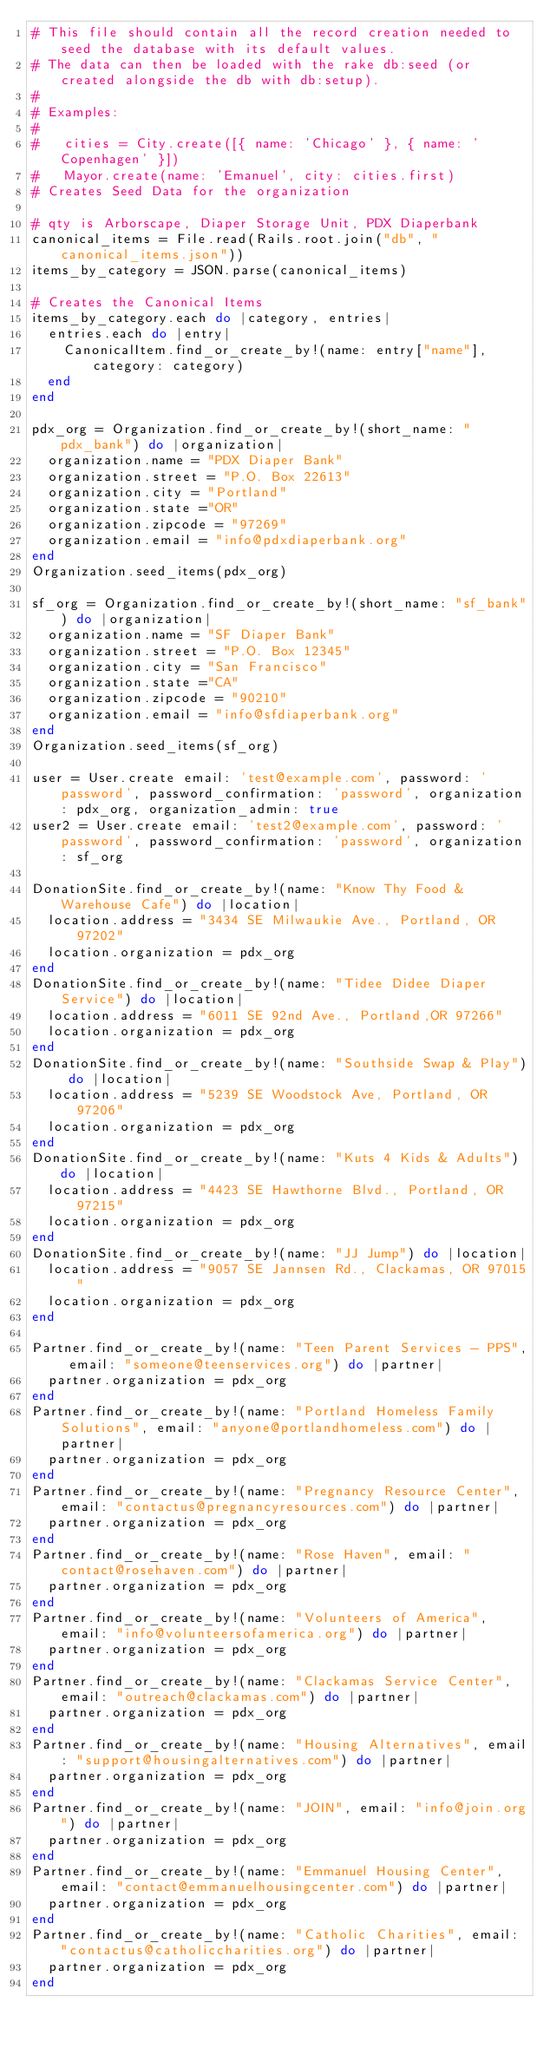<code> <loc_0><loc_0><loc_500><loc_500><_Ruby_># This file should contain all the record creation needed to seed the database with its default values.
# The data can then be loaded with the rake db:seed (or created alongside the db with db:setup).
#
# Examples:
#
#   cities = City.create([{ name: 'Chicago' }, { name: 'Copenhagen' }])
#   Mayor.create(name: 'Emanuel', city: cities.first)
# Creates Seed Data for the organization

# qty is Arborscape, Diaper Storage Unit, PDX Diaperbank
canonical_items = File.read(Rails.root.join("db", "canonical_items.json"))
items_by_category = JSON.parse(canonical_items)

# Creates the Canonical Items
items_by_category.each do |category, entries|
  entries.each do |entry|
    CanonicalItem.find_or_create_by!(name: entry["name"], category: category)
  end
end

pdx_org = Organization.find_or_create_by!(short_name: "pdx_bank") do |organization|
  organization.name = "PDX Diaper Bank"
  organization.street = "P.O. Box 22613"
  organization.city = "Portland"
  organization.state ="OR"
  organization.zipcode = "97269"
  organization.email = "info@pdxdiaperbank.org"
end
Organization.seed_items(pdx_org)

sf_org = Organization.find_or_create_by!(short_name: "sf_bank") do |organization|
  organization.name = "SF Diaper Bank"
  organization.street = "P.O. Box 12345"
  organization.city = "San Francisco"
  organization.state ="CA"
  organization.zipcode = "90210"
  organization.email = "info@sfdiaperbank.org"
end
Organization.seed_items(sf_org)

user = User.create email: 'test@example.com', password: 'password', password_confirmation: 'password', organization: pdx_org, organization_admin: true
user2 = User.create email: 'test2@example.com', password: 'password', password_confirmation: 'password', organization: sf_org

DonationSite.find_or_create_by!(name: "Know Thy Food & Warehouse Cafe") do |location|
  location.address = "3434 SE Milwaukie Ave., Portland, OR 97202"
  location.organization = pdx_org
end
DonationSite.find_or_create_by!(name: "Tidee Didee Diaper Service") do |location|
  location.address = "6011 SE 92nd Ave., Portland,OR 97266"
  location.organization = pdx_org
end
DonationSite.find_or_create_by!(name: "Southside Swap & Play") do |location|
  location.address = "5239 SE Woodstock Ave, Portland, OR 97206"
  location.organization = pdx_org
end
DonationSite.find_or_create_by!(name: "Kuts 4 Kids & Adults") do |location|
  location.address = "4423 SE Hawthorne Blvd., Portland, OR 97215"
  location.organization = pdx_org
end
DonationSite.find_or_create_by!(name: "JJ Jump") do |location|
  location.address = "9057 SE Jannsen Rd., Clackamas, OR 97015"
  location.organization = pdx_org
end

Partner.find_or_create_by!(name: "Teen Parent Services - PPS", email: "someone@teenservices.org") do |partner|
  partner.organization = pdx_org
end
Partner.find_or_create_by!(name: "Portland Homeless Family Solutions", email: "anyone@portlandhomeless.com") do |partner|
  partner.organization = pdx_org
end
Partner.find_or_create_by!(name: "Pregnancy Resource Center", email: "contactus@pregnancyresources.com") do |partner|
  partner.organization = pdx_org
end
Partner.find_or_create_by!(name: "Rose Haven", email: "contact@rosehaven.com") do |partner|
  partner.organization = pdx_org
end
Partner.find_or_create_by!(name: "Volunteers of America", email: "info@volunteersofamerica.org") do |partner|
  partner.organization = pdx_org
end
Partner.find_or_create_by!(name: "Clackamas Service Center", email: "outreach@clackamas.com") do |partner|
  partner.organization = pdx_org
end
Partner.find_or_create_by!(name: "Housing Alternatives", email: "support@housingalternatives.com") do |partner|
  partner.organization = pdx_org
end
Partner.find_or_create_by!(name: "JOIN", email: "info@join.org") do |partner|
  partner.organization = pdx_org
end
Partner.find_or_create_by!(name: "Emmanuel Housing Center", email: "contact@emmanuelhousingcenter.com") do |partner|
  partner.organization = pdx_org
end
Partner.find_or_create_by!(name: "Catholic Charities", email: "contactus@catholiccharities.org") do |partner|
  partner.organization = pdx_org
end</code> 